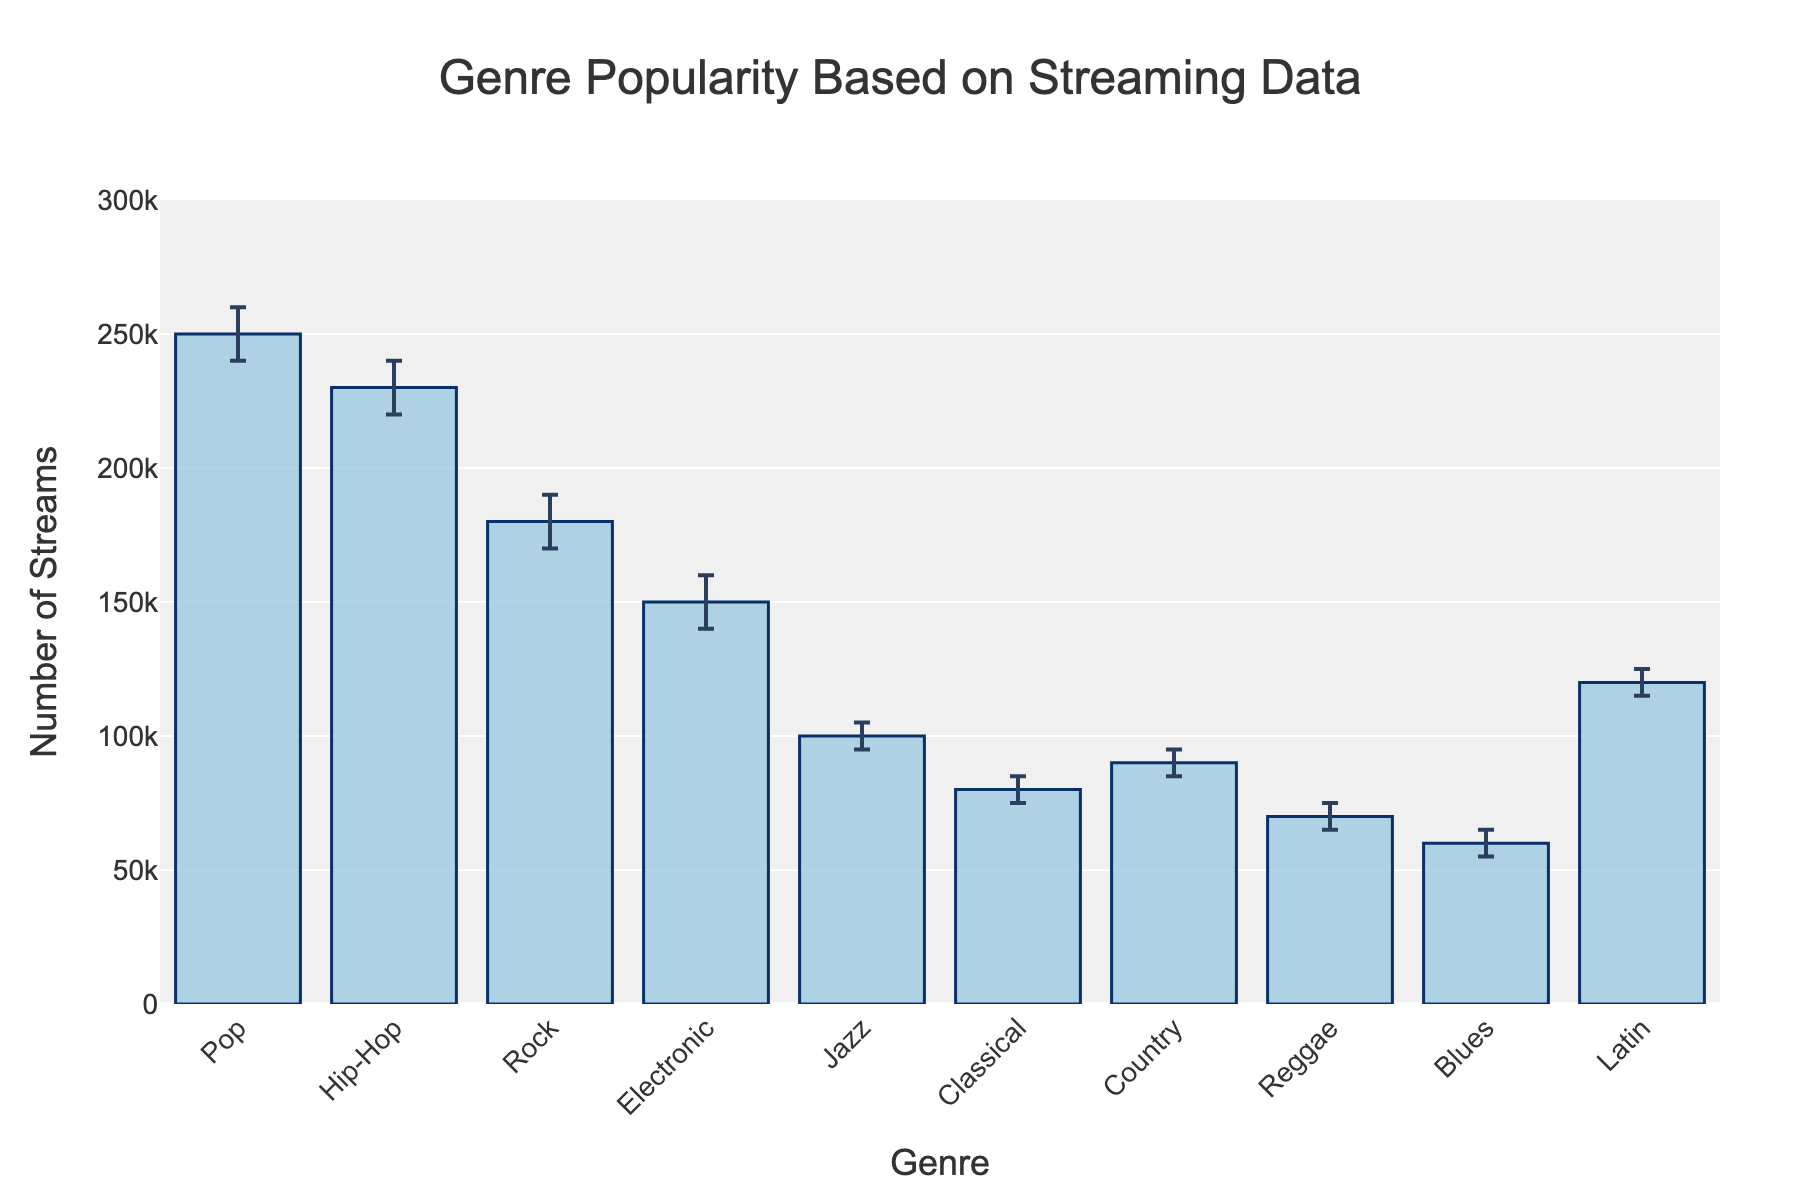what is the highest value for a genre in terms of number of streams? Looking at the bars and the error bars, the genre with the highest mean number of streams is Pop with a mean of 250,000 streams. The error bars show the confidence interval extending from 240,000 to 260,000.
Answer: 250,000 How many genres have a mean number of streams greater than 200,000? By examining the y-values on the figure, only Pop and Hip-Hop have mean stream numbers exceeding 200,000. Pop has a mean of 250,000 and Hip-Hop has a mean of 230,000.
Answer: 2 Which genre has the smallest upper confidence interval value? We check the upper confidence interval for all genres. Reggae has the smallest upper confidence interval of 75,000.
Answer: Reggae What is the difference in mean number of streams between Jazz and Latin genres? The mean number of streams for Jazz is 100,000 and for Latin is 120,000. Subtracting these values gives us 120,000 - 100,000.
Answer: 20,000 Which genre has the largest error interval in number of streams? The error interval is the difference between the upper and lower confidence intervals. Pop has a range of 20,000 (260,000 - 240,000), which is the largest interval among the genres.
Answer: Pop What is the total mean number of streams for Pop, Rock, and Jazz? Adding the mean number of streams for Pop (250,000), Rock (180,000), and Jazz (100,000) gives 250,000 + 180,000 + 100,000.
Answer: 530,000 Are there any genres with asymmetric error bars? Checking the error bars, we see that all bars are indeed asymmetric. For example, Pop has a higher distance from mean to upper bound (10,000) compared to mean to lower bound (10,000).
Answer: Yes Which genre has the smallest mean number of streams? By examining the values for mean number of streams, Reggae has the smallest mean number of streams with 70,000.
Answer: Reggae What is the range of the y-axis in the figure? Observing the y-axis, it ranges from 0 to 300,000 streams.
Answer: 0 to 300,000 